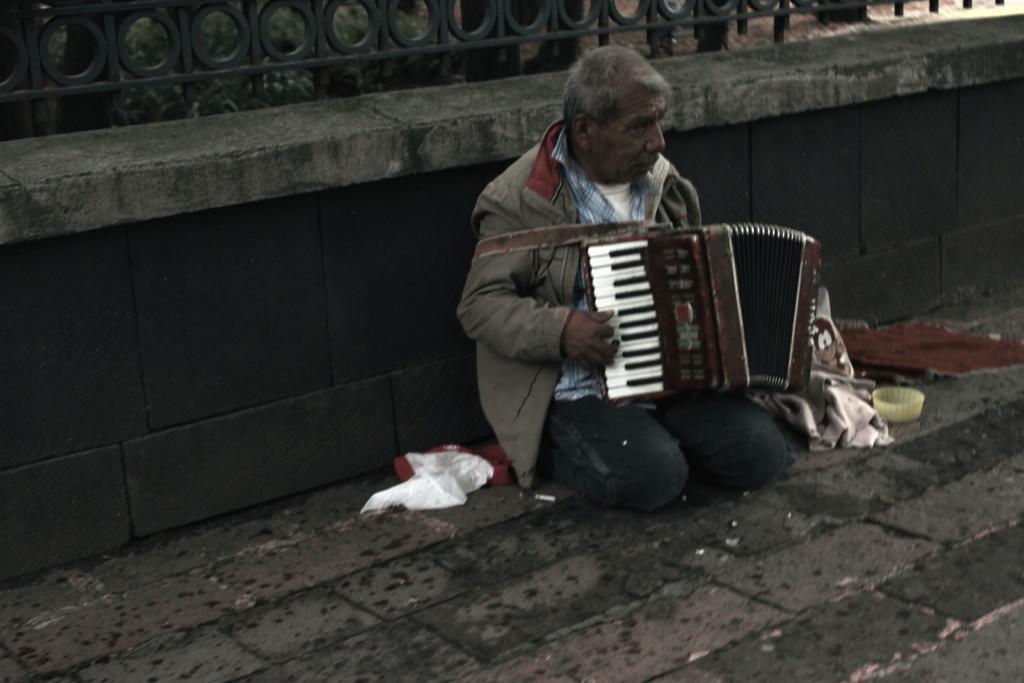Can you describe this image briefly? In this image in the center there is one person who is sitting and he is holding a musical instrument and playing, and beside him there are some clothes and bowl. At the bottom there is a floor, in the background there is a wall. 